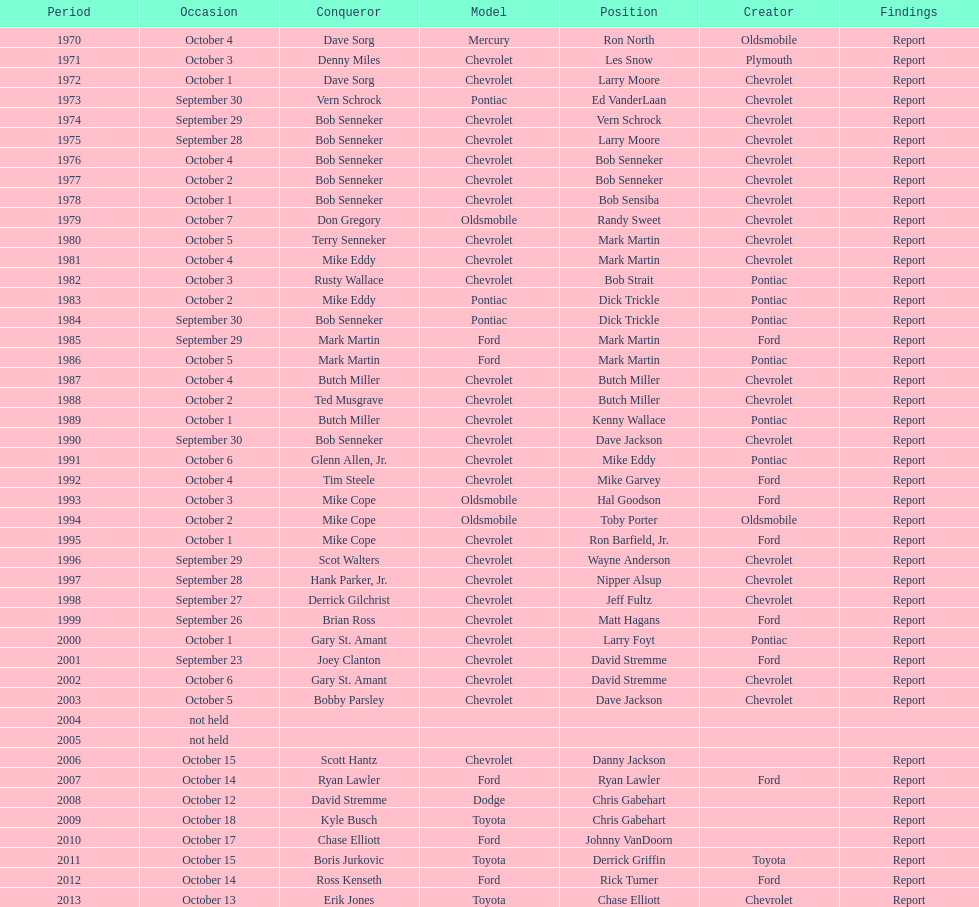Which month held the most winchester 400 races? October. 